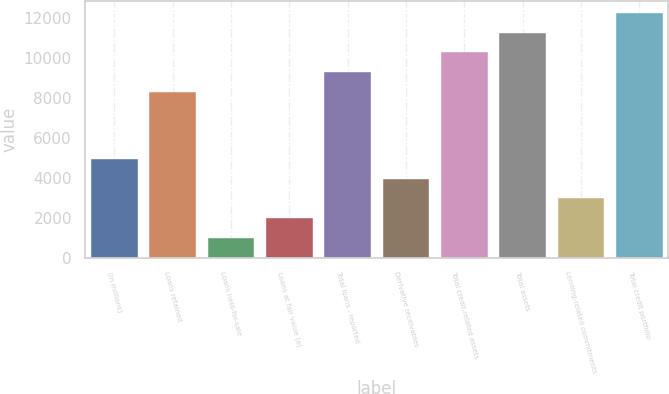Convert chart to OTSL. <chart><loc_0><loc_0><loc_500><loc_500><bar_chart><fcel>(in millions)<fcel>Loans retained<fcel>Loans held-for-sale<fcel>Loans at fair value (a)<fcel>Total loans - reported<fcel>Derivative receivables<fcel>Total credit-related assets<fcel>Total assets<fcel>Lending-related commitments<fcel>Total credit portfolio<nl><fcel>4958.5<fcel>8317<fcel>995.7<fcel>1986.4<fcel>9307.7<fcel>3967.8<fcel>10298.4<fcel>11289.1<fcel>2977.1<fcel>12279.8<nl></chart> 